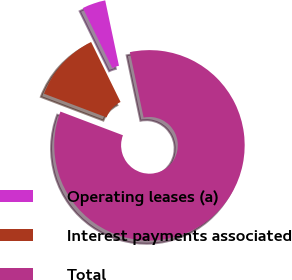Convert chart to OTSL. <chart><loc_0><loc_0><loc_500><loc_500><pie_chart><fcel>Operating leases (a)<fcel>Interest payments associated<fcel>Total<nl><fcel>3.96%<fcel>11.97%<fcel>84.07%<nl></chart> 